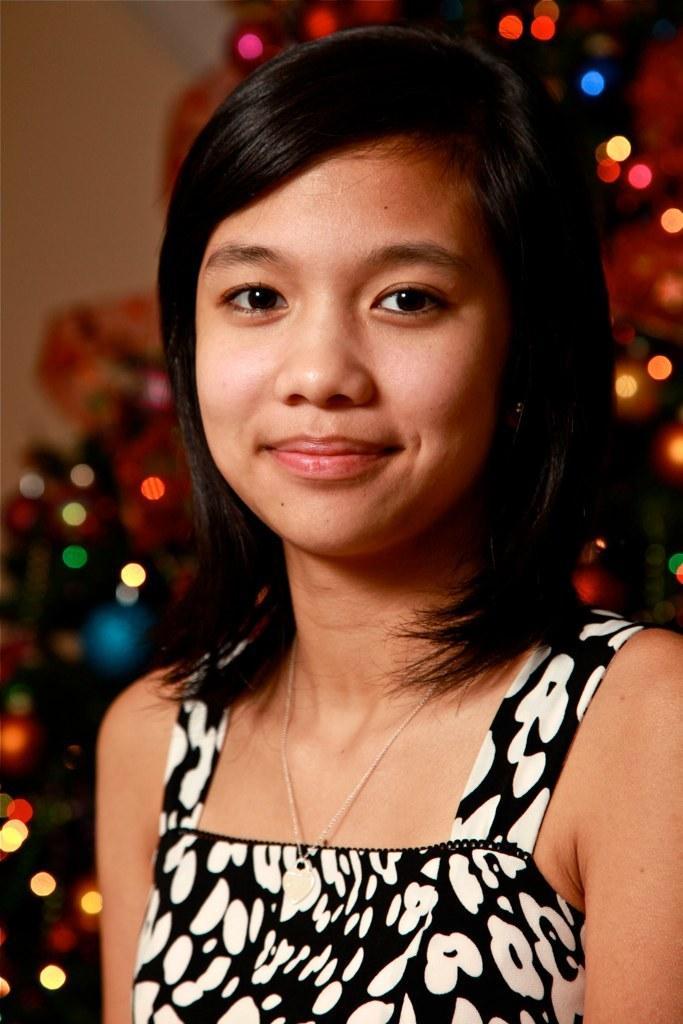Please provide a concise description of this image. In this picture we can see a woman, she is smiling, behind to her we can see few lights. 